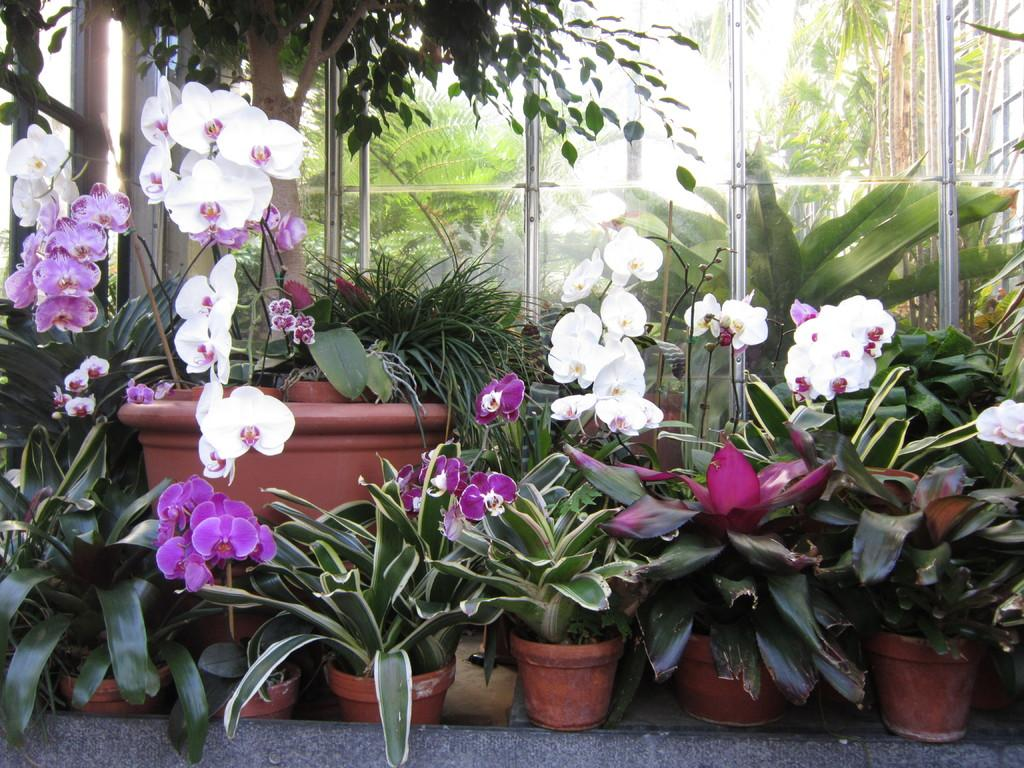What can be seen in the foreground of the picture? There are plants, flower pots, and flowers in the foreground of the picture. What type of plants are visible in the foreground? The specific type of plants cannot be determined from the image, but they are present in the foreground. What is the central feature of the picture? There is a glass door in the center of the picture. What grade does the flower pot receive for its performance in the image? There is no grading system or performance evaluation for the flower pot in the image. --- Facts: 1. There is a person sitting on a chair in the image. 2. The person is holding a book. 3. The book has a blue cover. 4. There is a table next to the chair. 5. There is a lamp on the table. Absurd Topics: dance, ocean, parrot Conversation: What is the person in the image doing? The person is sitting on a chair in the image. What is the person holding in the image? The person is holding a book in the image. What color is the book's cover? The book has a blue cover. What is located next to the chair in the image? There is a table next to the chair in the image. What object is on the table in the image? There is a lamp on the table in the image. Reasoning: Let's think step by step in order to produce the conversation. We start by identifying the main subject in the image, which is the person sitting on a chair. Then, we expand the conversation to include other items that are also visible, such as the book, the book's cover color, the table, and the lamp. Each question is designed to elicit a specific detail about the image that is known from the provided facts. Absurd Question/Answer: Can you see the ocean in the background of the image? No, there is no ocean visible in the image. 